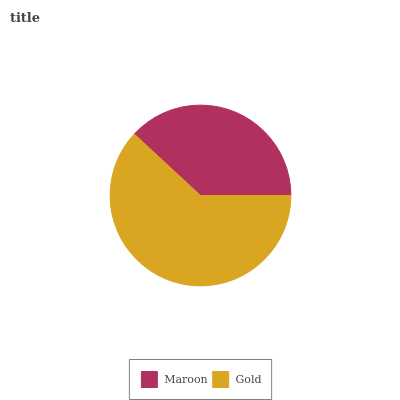Is Maroon the minimum?
Answer yes or no. Yes. Is Gold the maximum?
Answer yes or no. Yes. Is Gold the minimum?
Answer yes or no. No. Is Gold greater than Maroon?
Answer yes or no. Yes. Is Maroon less than Gold?
Answer yes or no. Yes. Is Maroon greater than Gold?
Answer yes or no. No. Is Gold less than Maroon?
Answer yes or no. No. Is Gold the high median?
Answer yes or no. Yes. Is Maroon the low median?
Answer yes or no. Yes. Is Maroon the high median?
Answer yes or no. No. Is Gold the low median?
Answer yes or no. No. 